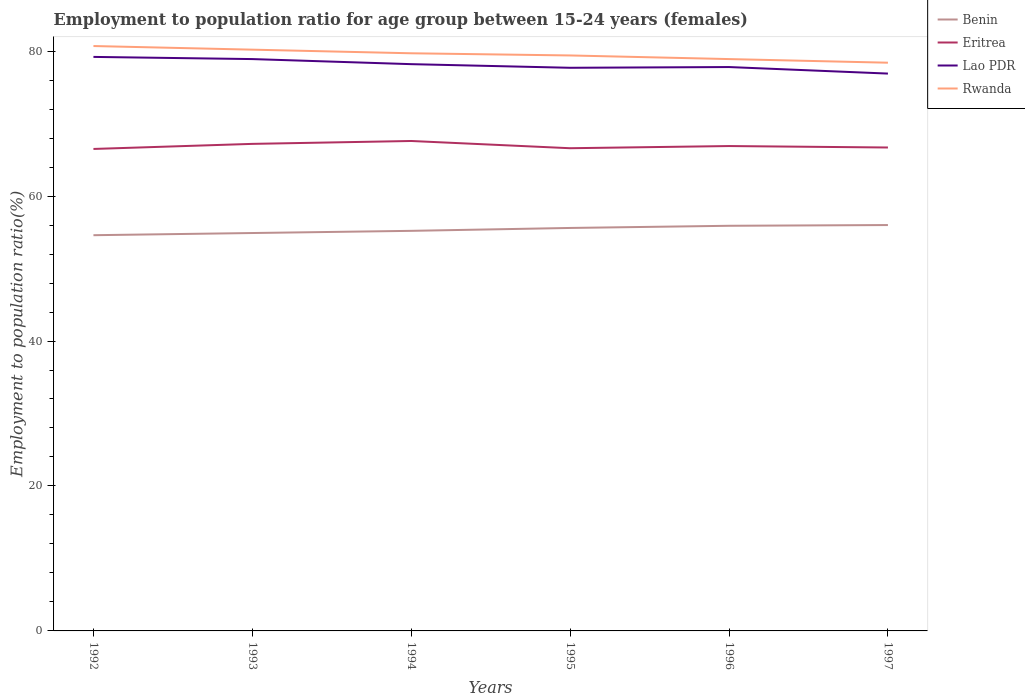Across all years, what is the maximum employment to population ratio in Rwanda?
Ensure brevity in your answer.  78.4. In which year was the employment to population ratio in Benin maximum?
Provide a short and direct response. 1992. What is the difference between the highest and the second highest employment to population ratio in Benin?
Offer a very short reply. 1.4. Is the employment to population ratio in Benin strictly greater than the employment to population ratio in Rwanda over the years?
Your answer should be very brief. Yes. How many lines are there?
Provide a succinct answer. 4. What is the difference between two consecutive major ticks on the Y-axis?
Ensure brevity in your answer.  20. Are the values on the major ticks of Y-axis written in scientific E-notation?
Provide a succinct answer. No. Does the graph contain grids?
Your answer should be very brief. No. How many legend labels are there?
Offer a terse response. 4. What is the title of the graph?
Offer a very short reply. Employment to population ratio for age group between 15-24 years (females). Does "Moldova" appear as one of the legend labels in the graph?
Keep it short and to the point. No. What is the label or title of the Y-axis?
Your answer should be very brief. Employment to population ratio(%). What is the Employment to population ratio(%) of Benin in 1992?
Give a very brief answer. 54.6. What is the Employment to population ratio(%) in Eritrea in 1992?
Your answer should be compact. 66.5. What is the Employment to population ratio(%) in Lao PDR in 1992?
Make the answer very short. 79.2. What is the Employment to population ratio(%) in Rwanda in 1992?
Provide a short and direct response. 80.7. What is the Employment to population ratio(%) in Benin in 1993?
Make the answer very short. 54.9. What is the Employment to population ratio(%) in Eritrea in 1993?
Provide a short and direct response. 67.2. What is the Employment to population ratio(%) of Lao PDR in 1993?
Provide a succinct answer. 78.9. What is the Employment to population ratio(%) in Rwanda in 1993?
Provide a short and direct response. 80.2. What is the Employment to population ratio(%) in Benin in 1994?
Your answer should be very brief. 55.2. What is the Employment to population ratio(%) in Eritrea in 1994?
Provide a short and direct response. 67.6. What is the Employment to population ratio(%) of Lao PDR in 1994?
Offer a very short reply. 78.2. What is the Employment to population ratio(%) in Rwanda in 1994?
Provide a succinct answer. 79.7. What is the Employment to population ratio(%) in Benin in 1995?
Provide a short and direct response. 55.6. What is the Employment to population ratio(%) of Eritrea in 1995?
Keep it short and to the point. 66.6. What is the Employment to population ratio(%) in Lao PDR in 1995?
Your answer should be very brief. 77.7. What is the Employment to population ratio(%) of Rwanda in 1995?
Your answer should be very brief. 79.4. What is the Employment to population ratio(%) of Benin in 1996?
Provide a short and direct response. 55.9. What is the Employment to population ratio(%) of Eritrea in 1996?
Give a very brief answer. 66.9. What is the Employment to population ratio(%) of Lao PDR in 1996?
Keep it short and to the point. 77.8. What is the Employment to population ratio(%) of Rwanda in 1996?
Offer a very short reply. 78.9. What is the Employment to population ratio(%) in Eritrea in 1997?
Ensure brevity in your answer.  66.7. What is the Employment to population ratio(%) of Lao PDR in 1997?
Your response must be concise. 76.9. What is the Employment to population ratio(%) in Rwanda in 1997?
Ensure brevity in your answer.  78.4. Across all years, what is the maximum Employment to population ratio(%) in Benin?
Provide a short and direct response. 56. Across all years, what is the maximum Employment to population ratio(%) in Eritrea?
Provide a short and direct response. 67.6. Across all years, what is the maximum Employment to population ratio(%) of Lao PDR?
Your response must be concise. 79.2. Across all years, what is the maximum Employment to population ratio(%) in Rwanda?
Give a very brief answer. 80.7. Across all years, what is the minimum Employment to population ratio(%) of Benin?
Ensure brevity in your answer.  54.6. Across all years, what is the minimum Employment to population ratio(%) in Eritrea?
Offer a terse response. 66.5. Across all years, what is the minimum Employment to population ratio(%) of Lao PDR?
Keep it short and to the point. 76.9. Across all years, what is the minimum Employment to population ratio(%) of Rwanda?
Your answer should be very brief. 78.4. What is the total Employment to population ratio(%) of Benin in the graph?
Offer a terse response. 332.2. What is the total Employment to population ratio(%) of Eritrea in the graph?
Your answer should be compact. 401.5. What is the total Employment to population ratio(%) in Lao PDR in the graph?
Ensure brevity in your answer.  468.7. What is the total Employment to population ratio(%) of Rwanda in the graph?
Give a very brief answer. 477.3. What is the difference between the Employment to population ratio(%) in Lao PDR in 1992 and that in 1993?
Give a very brief answer. 0.3. What is the difference between the Employment to population ratio(%) in Lao PDR in 1992 and that in 1994?
Your answer should be very brief. 1. What is the difference between the Employment to population ratio(%) in Eritrea in 1992 and that in 1995?
Your answer should be very brief. -0.1. What is the difference between the Employment to population ratio(%) of Benin in 1992 and that in 1996?
Your answer should be very brief. -1.3. What is the difference between the Employment to population ratio(%) in Rwanda in 1992 and that in 1996?
Offer a very short reply. 1.8. What is the difference between the Employment to population ratio(%) of Benin in 1993 and that in 1994?
Give a very brief answer. -0.3. What is the difference between the Employment to population ratio(%) in Eritrea in 1993 and that in 1994?
Make the answer very short. -0.4. What is the difference between the Employment to population ratio(%) of Rwanda in 1993 and that in 1994?
Give a very brief answer. 0.5. What is the difference between the Employment to population ratio(%) of Benin in 1993 and that in 1995?
Your answer should be very brief. -0.7. What is the difference between the Employment to population ratio(%) of Eritrea in 1993 and that in 1995?
Keep it short and to the point. 0.6. What is the difference between the Employment to population ratio(%) in Benin in 1993 and that in 1996?
Offer a very short reply. -1. What is the difference between the Employment to population ratio(%) in Eritrea in 1993 and that in 1996?
Give a very brief answer. 0.3. What is the difference between the Employment to population ratio(%) in Lao PDR in 1993 and that in 1996?
Offer a very short reply. 1.1. What is the difference between the Employment to population ratio(%) in Rwanda in 1993 and that in 1996?
Keep it short and to the point. 1.3. What is the difference between the Employment to population ratio(%) of Benin in 1993 and that in 1997?
Keep it short and to the point. -1.1. What is the difference between the Employment to population ratio(%) of Eritrea in 1994 and that in 1995?
Give a very brief answer. 1. What is the difference between the Employment to population ratio(%) of Rwanda in 1994 and that in 1995?
Your answer should be compact. 0.3. What is the difference between the Employment to population ratio(%) in Lao PDR in 1994 and that in 1996?
Your response must be concise. 0.4. What is the difference between the Employment to population ratio(%) of Eritrea in 1994 and that in 1997?
Your answer should be very brief. 0.9. What is the difference between the Employment to population ratio(%) in Lao PDR in 1994 and that in 1997?
Ensure brevity in your answer.  1.3. What is the difference between the Employment to population ratio(%) in Benin in 1995 and that in 1996?
Give a very brief answer. -0.3. What is the difference between the Employment to population ratio(%) in Eritrea in 1995 and that in 1996?
Keep it short and to the point. -0.3. What is the difference between the Employment to population ratio(%) of Eritrea in 1995 and that in 1997?
Provide a short and direct response. -0.1. What is the difference between the Employment to population ratio(%) of Rwanda in 1995 and that in 1997?
Your response must be concise. 1. What is the difference between the Employment to population ratio(%) in Benin in 1996 and that in 1997?
Offer a very short reply. -0.1. What is the difference between the Employment to population ratio(%) of Lao PDR in 1996 and that in 1997?
Provide a short and direct response. 0.9. What is the difference between the Employment to population ratio(%) of Benin in 1992 and the Employment to population ratio(%) of Lao PDR in 1993?
Your answer should be compact. -24.3. What is the difference between the Employment to population ratio(%) of Benin in 1992 and the Employment to population ratio(%) of Rwanda in 1993?
Your answer should be very brief. -25.6. What is the difference between the Employment to population ratio(%) in Eritrea in 1992 and the Employment to population ratio(%) in Rwanda in 1993?
Provide a succinct answer. -13.7. What is the difference between the Employment to population ratio(%) of Benin in 1992 and the Employment to population ratio(%) of Lao PDR in 1994?
Make the answer very short. -23.6. What is the difference between the Employment to population ratio(%) in Benin in 1992 and the Employment to population ratio(%) in Rwanda in 1994?
Your answer should be compact. -25.1. What is the difference between the Employment to population ratio(%) in Eritrea in 1992 and the Employment to population ratio(%) in Lao PDR in 1994?
Your answer should be very brief. -11.7. What is the difference between the Employment to population ratio(%) in Eritrea in 1992 and the Employment to population ratio(%) in Rwanda in 1994?
Your response must be concise. -13.2. What is the difference between the Employment to population ratio(%) in Benin in 1992 and the Employment to population ratio(%) in Lao PDR in 1995?
Offer a terse response. -23.1. What is the difference between the Employment to population ratio(%) in Benin in 1992 and the Employment to population ratio(%) in Rwanda in 1995?
Your response must be concise. -24.8. What is the difference between the Employment to population ratio(%) of Eritrea in 1992 and the Employment to population ratio(%) of Rwanda in 1995?
Give a very brief answer. -12.9. What is the difference between the Employment to population ratio(%) in Lao PDR in 1992 and the Employment to population ratio(%) in Rwanda in 1995?
Ensure brevity in your answer.  -0.2. What is the difference between the Employment to population ratio(%) of Benin in 1992 and the Employment to population ratio(%) of Lao PDR in 1996?
Ensure brevity in your answer.  -23.2. What is the difference between the Employment to population ratio(%) of Benin in 1992 and the Employment to population ratio(%) of Rwanda in 1996?
Keep it short and to the point. -24.3. What is the difference between the Employment to population ratio(%) in Eritrea in 1992 and the Employment to population ratio(%) in Lao PDR in 1996?
Keep it short and to the point. -11.3. What is the difference between the Employment to population ratio(%) of Lao PDR in 1992 and the Employment to population ratio(%) of Rwanda in 1996?
Give a very brief answer. 0.3. What is the difference between the Employment to population ratio(%) of Benin in 1992 and the Employment to population ratio(%) of Lao PDR in 1997?
Make the answer very short. -22.3. What is the difference between the Employment to population ratio(%) of Benin in 1992 and the Employment to population ratio(%) of Rwanda in 1997?
Provide a short and direct response. -23.8. What is the difference between the Employment to population ratio(%) of Lao PDR in 1992 and the Employment to population ratio(%) of Rwanda in 1997?
Your answer should be very brief. 0.8. What is the difference between the Employment to population ratio(%) of Benin in 1993 and the Employment to population ratio(%) of Lao PDR in 1994?
Provide a succinct answer. -23.3. What is the difference between the Employment to population ratio(%) of Benin in 1993 and the Employment to population ratio(%) of Rwanda in 1994?
Keep it short and to the point. -24.8. What is the difference between the Employment to population ratio(%) of Eritrea in 1993 and the Employment to population ratio(%) of Lao PDR in 1994?
Give a very brief answer. -11. What is the difference between the Employment to population ratio(%) in Benin in 1993 and the Employment to population ratio(%) in Lao PDR in 1995?
Make the answer very short. -22.8. What is the difference between the Employment to population ratio(%) of Benin in 1993 and the Employment to population ratio(%) of Rwanda in 1995?
Provide a short and direct response. -24.5. What is the difference between the Employment to population ratio(%) in Eritrea in 1993 and the Employment to population ratio(%) in Lao PDR in 1995?
Give a very brief answer. -10.5. What is the difference between the Employment to population ratio(%) of Lao PDR in 1993 and the Employment to population ratio(%) of Rwanda in 1995?
Ensure brevity in your answer.  -0.5. What is the difference between the Employment to population ratio(%) of Benin in 1993 and the Employment to population ratio(%) of Eritrea in 1996?
Ensure brevity in your answer.  -12. What is the difference between the Employment to population ratio(%) of Benin in 1993 and the Employment to population ratio(%) of Lao PDR in 1996?
Offer a very short reply. -22.9. What is the difference between the Employment to population ratio(%) in Eritrea in 1993 and the Employment to population ratio(%) in Lao PDR in 1996?
Offer a terse response. -10.6. What is the difference between the Employment to population ratio(%) in Eritrea in 1993 and the Employment to population ratio(%) in Rwanda in 1996?
Offer a very short reply. -11.7. What is the difference between the Employment to population ratio(%) in Lao PDR in 1993 and the Employment to population ratio(%) in Rwanda in 1996?
Offer a very short reply. 0. What is the difference between the Employment to population ratio(%) in Benin in 1993 and the Employment to population ratio(%) in Eritrea in 1997?
Provide a short and direct response. -11.8. What is the difference between the Employment to population ratio(%) in Benin in 1993 and the Employment to population ratio(%) in Lao PDR in 1997?
Your answer should be compact. -22. What is the difference between the Employment to population ratio(%) of Benin in 1993 and the Employment to population ratio(%) of Rwanda in 1997?
Make the answer very short. -23.5. What is the difference between the Employment to population ratio(%) of Eritrea in 1993 and the Employment to population ratio(%) of Lao PDR in 1997?
Your answer should be very brief. -9.7. What is the difference between the Employment to population ratio(%) in Eritrea in 1993 and the Employment to population ratio(%) in Rwanda in 1997?
Keep it short and to the point. -11.2. What is the difference between the Employment to population ratio(%) in Benin in 1994 and the Employment to population ratio(%) in Eritrea in 1995?
Ensure brevity in your answer.  -11.4. What is the difference between the Employment to population ratio(%) of Benin in 1994 and the Employment to population ratio(%) of Lao PDR in 1995?
Give a very brief answer. -22.5. What is the difference between the Employment to population ratio(%) of Benin in 1994 and the Employment to population ratio(%) of Rwanda in 1995?
Your answer should be very brief. -24.2. What is the difference between the Employment to population ratio(%) of Eritrea in 1994 and the Employment to population ratio(%) of Lao PDR in 1995?
Your answer should be compact. -10.1. What is the difference between the Employment to population ratio(%) in Benin in 1994 and the Employment to population ratio(%) in Lao PDR in 1996?
Provide a short and direct response. -22.6. What is the difference between the Employment to population ratio(%) in Benin in 1994 and the Employment to population ratio(%) in Rwanda in 1996?
Offer a very short reply. -23.7. What is the difference between the Employment to population ratio(%) of Lao PDR in 1994 and the Employment to population ratio(%) of Rwanda in 1996?
Provide a short and direct response. -0.7. What is the difference between the Employment to population ratio(%) in Benin in 1994 and the Employment to population ratio(%) in Eritrea in 1997?
Offer a terse response. -11.5. What is the difference between the Employment to population ratio(%) of Benin in 1994 and the Employment to population ratio(%) of Lao PDR in 1997?
Provide a short and direct response. -21.7. What is the difference between the Employment to population ratio(%) of Benin in 1994 and the Employment to population ratio(%) of Rwanda in 1997?
Your answer should be compact. -23.2. What is the difference between the Employment to population ratio(%) of Eritrea in 1994 and the Employment to population ratio(%) of Lao PDR in 1997?
Ensure brevity in your answer.  -9.3. What is the difference between the Employment to population ratio(%) of Benin in 1995 and the Employment to population ratio(%) of Eritrea in 1996?
Provide a short and direct response. -11.3. What is the difference between the Employment to population ratio(%) of Benin in 1995 and the Employment to population ratio(%) of Lao PDR in 1996?
Give a very brief answer. -22.2. What is the difference between the Employment to population ratio(%) of Benin in 1995 and the Employment to population ratio(%) of Rwanda in 1996?
Provide a succinct answer. -23.3. What is the difference between the Employment to population ratio(%) in Benin in 1995 and the Employment to population ratio(%) in Eritrea in 1997?
Your answer should be very brief. -11.1. What is the difference between the Employment to population ratio(%) of Benin in 1995 and the Employment to population ratio(%) of Lao PDR in 1997?
Your response must be concise. -21.3. What is the difference between the Employment to population ratio(%) in Benin in 1995 and the Employment to population ratio(%) in Rwanda in 1997?
Offer a terse response. -22.8. What is the difference between the Employment to population ratio(%) of Eritrea in 1995 and the Employment to population ratio(%) of Lao PDR in 1997?
Your answer should be very brief. -10.3. What is the difference between the Employment to population ratio(%) in Benin in 1996 and the Employment to population ratio(%) in Eritrea in 1997?
Provide a short and direct response. -10.8. What is the difference between the Employment to population ratio(%) in Benin in 1996 and the Employment to population ratio(%) in Rwanda in 1997?
Provide a short and direct response. -22.5. What is the average Employment to population ratio(%) of Benin per year?
Your response must be concise. 55.37. What is the average Employment to population ratio(%) in Eritrea per year?
Your answer should be very brief. 66.92. What is the average Employment to population ratio(%) in Lao PDR per year?
Your response must be concise. 78.12. What is the average Employment to population ratio(%) of Rwanda per year?
Make the answer very short. 79.55. In the year 1992, what is the difference between the Employment to population ratio(%) of Benin and Employment to population ratio(%) of Eritrea?
Your response must be concise. -11.9. In the year 1992, what is the difference between the Employment to population ratio(%) of Benin and Employment to population ratio(%) of Lao PDR?
Your answer should be very brief. -24.6. In the year 1992, what is the difference between the Employment to population ratio(%) of Benin and Employment to population ratio(%) of Rwanda?
Give a very brief answer. -26.1. In the year 1992, what is the difference between the Employment to population ratio(%) of Lao PDR and Employment to population ratio(%) of Rwanda?
Give a very brief answer. -1.5. In the year 1993, what is the difference between the Employment to population ratio(%) of Benin and Employment to population ratio(%) of Eritrea?
Offer a terse response. -12.3. In the year 1993, what is the difference between the Employment to population ratio(%) of Benin and Employment to population ratio(%) of Rwanda?
Your response must be concise. -25.3. In the year 1993, what is the difference between the Employment to population ratio(%) in Lao PDR and Employment to population ratio(%) in Rwanda?
Provide a succinct answer. -1.3. In the year 1994, what is the difference between the Employment to population ratio(%) in Benin and Employment to population ratio(%) in Rwanda?
Provide a short and direct response. -24.5. In the year 1994, what is the difference between the Employment to population ratio(%) in Lao PDR and Employment to population ratio(%) in Rwanda?
Provide a short and direct response. -1.5. In the year 1995, what is the difference between the Employment to population ratio(%) in Benin and Employment to population ratio(%) in Lao PDR?
Make the answer very short. -22.1. In the year 1995, what is the difference between the Employment to population ratio(%) of Benin and Employment to population ratio(%) of Rwanda?
Make the answer very short. -23.8. In the year 1995, what is the difference between the Employment to population ratio(%) of Eritrea and Employment to population ratio(%) of Rwanda?
Keep it short and to the point. -12.8. In the year 1996, what is the difference between the Employment to population ratio(%) of Benin and Employment to population ratio(%) of Lao PDR?
Ensure brevity in your answer.  -21.9. In the year 1996, what is the difference between the Employment to population ratio(%) in Eritrea and Employment to population ratio(%) in Rwanda?
Provide a succinct answer. -12. In the year 1996, what is the difference between the Employment to population ratio(%) in Lao PDR and Employment to population ratio(%) in Rwanda?
Keep it short and to the point. -1.1. In the year 1997, what is the difference between the Employment to population ratio(%) of Benin and Employment to population ratio(%) of Lao PDR?
Offer a very short reply. -20.9. In the year 1997, what is the difference between the Employment to population ratio(%) of Benin and Employment to population ratio(%) of Rwanda?
Your response must be concise. -22.4. In the year 1997, what is the difference between the Employment to population ratio(%) in Eritrea and Employment to population ratio(%) in Lao PDR?
Your answer should be very brief. -10.2. In the year 1997, what is the difference between the Employment to population ratio(%) in Eritrea and Employment to population ratio(%) in Rwanda?
Provide a succinct answer. -11.7. What is the ratio of the Employment to population ratio(%) of Eritrea in 1992 to that in 1994?
Offer a terse response. 0.98. What is the ratio of the Employment to population ratio(%) in Lao PDR in 1992 to that in 1994?
Provide a short and direct response. 1.01. What is the ratio of the Employment to population ratio(%) in Rwanda in 1992 to that in 1994?
Provide a short and direct response. 1.01. What is the ratio of the Employment to population ratio(%) in Lao PDR in 1992 to that in 1995?
Give a very brief answer. 1.02. What is the ratio of the Employment to population ratio(%) of Rwanda in 1992 to that in 1995?
Give a very brief answer. 1.02. What is the ratio of the Employment to population ratio(%) of Benin in 1992 to that in 1996?
Make the answer very short. 0.98. What is the ratio of the Employment to population ratio(%) of Eritrea in 1992 to that in 1996?
Offer a very short reply. 0.99. What is the ratio of the Employment to population ratio(%) of Rwanda in 1992 to that in 1996?
Provide a succinct answer. 1.02. What is the ratio of the Employment to population ratio(%) of Eritrea in 1992 to that in 1997?
Give a very brief answer. 1. What is the ratio of the Employment to population ratio(%) in Lao PDR in 1992 to that in 1997?
Make the answer very short. 1.03. What is the ratio of the Employment to population ratio(%) of Rwanda in 1992 to that in 1997?
Your answer should be compact. 1.03. What is the ratio of the Employment to population ratio(%) of Benin in 1993 to that in 1994?
Ensure brevity in your answer.  0.99. What is the ratio of the Employment to population ratio(%) of Lao PDR in 1993 to that in 1994?
Keep it short and to the point. 1.01. What is the ratio of the Employment to population ratio(%) in Benin in 1993 to that in 1995?
Keep it short and to the point. 0.99. What is the ratio of the Employment to population ratio(%) in Eritrea in 1993 to that in 1995?
Your answer should be very brief. 1.01. What is the ratio of the Employment to population ratio(%) in Lao PDR in 1993 to that in 1995?
Your response must be concise. 1.02. What is the ratio of the Employment to population ratio(%) in Benin in 1993 to that in 1996?
Keep it short and to the point. 0.98. What is the ratio of the Employment to population ratio(%) of Eritrea in 1993 to that in 1996?
Keep it short and to the point. 1. What is the ratio of the Employment to population ratio(%) in Lao PDR in 1993 to that in 1996?
Provide a succinct answer. 1.01. What is the ratio of the Employment to population ratio(%) in Rwanda in 1993 to that in 1996?
Provide a short and direct response. 1.02. What is the ratio of the Employment to population ratio(%) of Benin in 1993 to that in 1997?
Your answer should be compact. 0.98. What is the ratio of the Employment to population ratio(%) in Eritrea in 1993 to that in 1997?
Give a very brief answer. 1.01. What is the ratio of the Employment to population ratio(%) in Lao PDR in 1993 to that in 1997?
Ensure brevity in your answer.  1.03. What is the ratio of the Employment to population ratio(%) in Rwanda in 1993 to that in 1997?
Your answer should be compact. 1.02. What is the ratio of the Employment to population ratio(%) of Benin in 1994 to that in 1995?
Give a very brief answer. 0.99. What is the ratio of the Employment to population ratio(%) in Lao PDR in 1994 to that in 1995?
Make the answer very short. 1.01. What is the ratio of the Employment to population ratio(%) in Benin in 1994 to that in 1996?
Provide a short and direct response. 0.99. What is the ratio of the Employment to population ratio(%) in Eritrea in 1994 to that in 1996?
Keep it short and to the point. 1.01. What is the ratio of the Employment to population ratio(%) of Benin in 1994 to that in 1997?
Give a very brief answer. 0.99. What is the ratio of the Employment to population ratio(%) of Eritrea in 1994 to that in 1997?
Your response must be concise. 1.01. What is the ratio of the Employment to population ratio(%) in Lao PDR in 1994 to that in 1997?
Give a very brief answer. 1.02. What is the ratio of the Employment to population ratio(%) of Rwanda in 1994 to that in 1997?
Make the answer very short. 1.02. What is the ratio of the Employment to population ratio(%) of Benin in 1995 to that in 1996?
Make the answer very short. 0.99. What is the ratio of the Employment to population ratio(%) in Rwanda in 1995 to that in 1996?
Your answer should be compact. 1.01. What is the ratio of the Employment to population ratio(%) in Eritrea in 1995 to that in 1997?
Provide a succinct answer. 1. What is the ratio of the Employment to population ratio(%) of Lao PDR in 1995 to that in 1997?
Make the answer very short. 1.01. What is the ratio of the Employment to population ratio(%) of Rwanda in 1995 to that in 1997?
Your answer should be very brief. 1.01. What is the ratio of the Employment to population ratio(%) in Benin in 1996 to that in 1997?
Your answer should be very brief. 1. What is the ratio of the Employment to population ratio(%) of Eritrea in 1996 to that in 1997?
Offer a very short reply. 1. What is the ratio of the Employment to population ratio(%) of Lao PDR in 1996 to that in 1997?
Your answer should be very brief. 1.01. What is the ratio of the Employment to population ratio(%) of Rwanda in 1996 to that in 1997?
Your answer should be compact. 1.01. What is the difference between the highest and the second highest Employment to population ratio(%) of Eritrea?
Offer a very short reply. 0.4. What is the difference between the highest and the lowest Employment to population ratio(%) of Eritrea?
Make the answer very short. 1.1. 